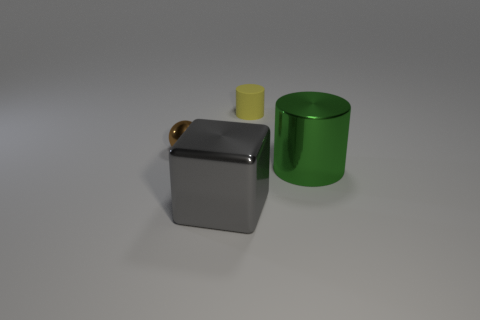Add 1 small shiny things. How many objects exist? 5 Subtract all blocks. How many objects are left? 3 Add 1 metallic objects. How many metallic objects exist? 4 Subtract 0 yellow spheres. How many objects are left? 4 Subtract all large blue shiny cylinders. Subtract all large things. How many objects are left? 2 Add 1 small yellow objects. How many small yellow objects are left? 2 